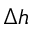<formula> <loc_0><loc_0><loc_500><loc_500>\Delta h</formula> 